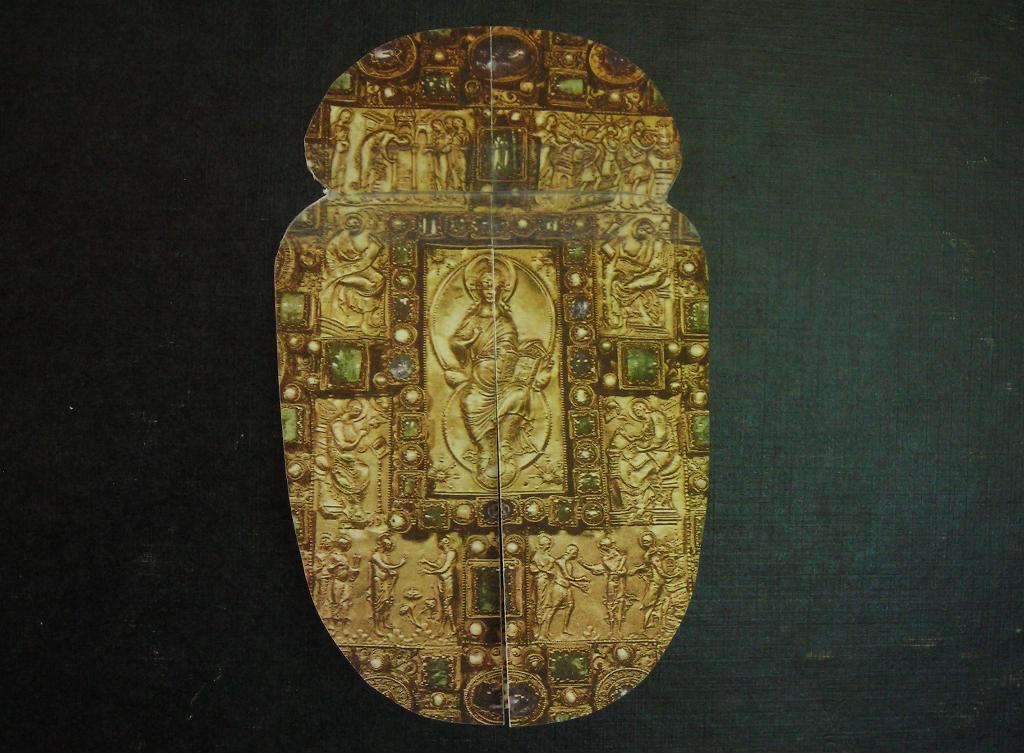What is the color of the main object in the image? The main object in the image is gold colored. What is placed on the gold colored object? There are stones on the gold colored object. What type of design can be seen on the gold colored object? There are carved person shapes on the gold colored object. What color is the background of the image? The background of the image is black. What is the texture of the middle of the gold colored object? There is no mention of a middle part of the gold colored object in the provided facts, so we cannot determine its texture. 